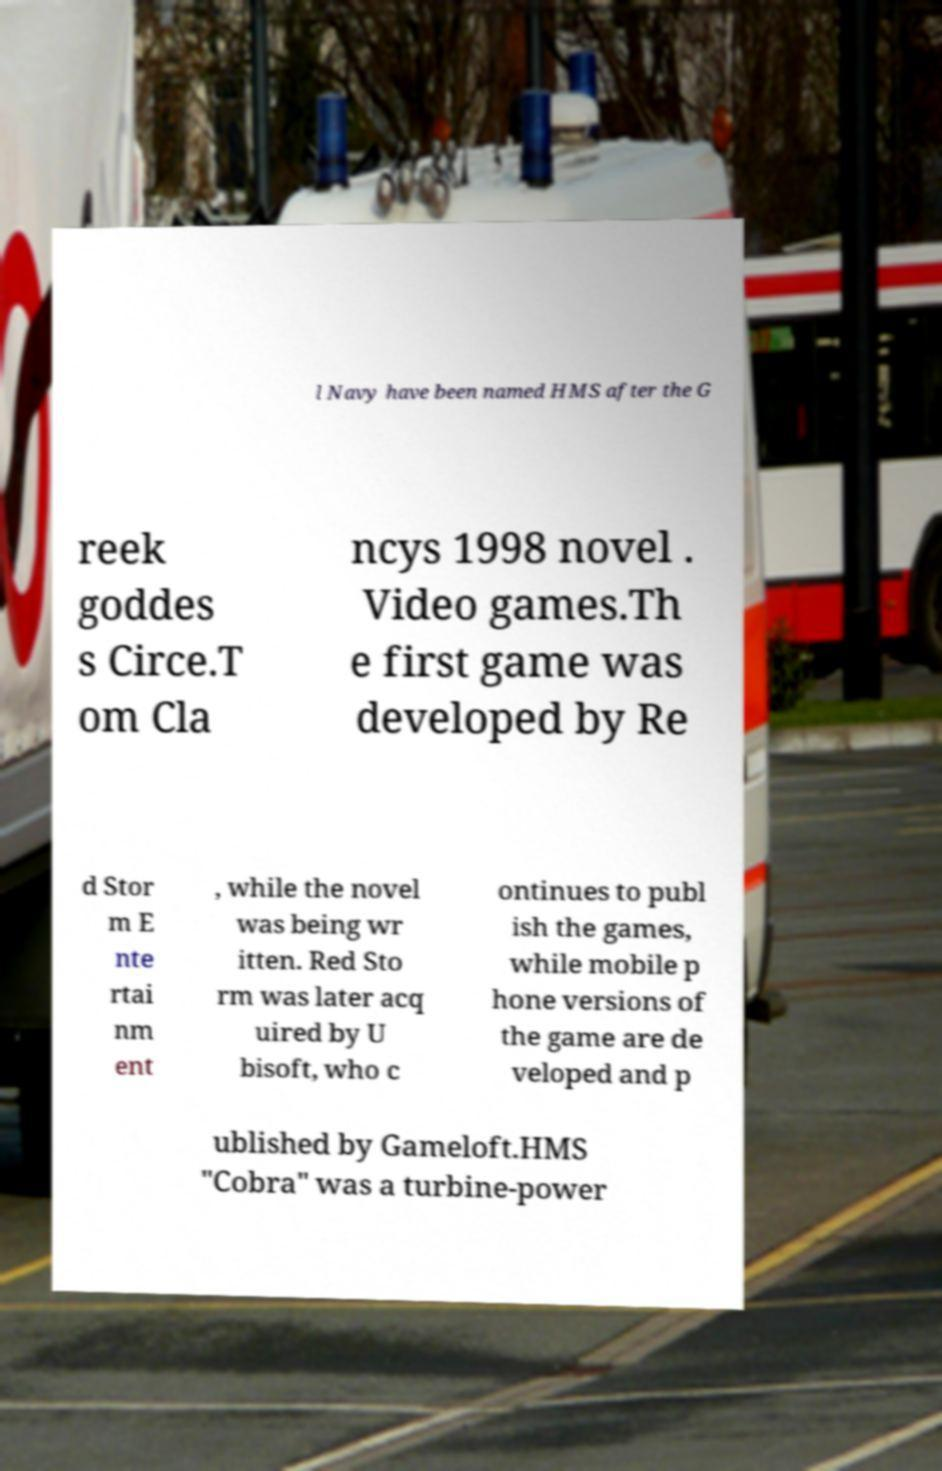There's text embedded in this image that I need extracted. Can you transcribe it verbatim? l Navy have been named HMS after the G reek goddes s Circe.T om Cla ncys 1998 novel . Video games.Th e first game was developed by Re d Stor m E nte rtai nm ent , while the novel was being wr itten. Red Sto rm was later acq uired by U bisoft, who c ontinues to publ ish the games, while mobile p hone versions of the game are de veloped and p ublished by Gameloft.HMS "Cobra" was a turbine-power 